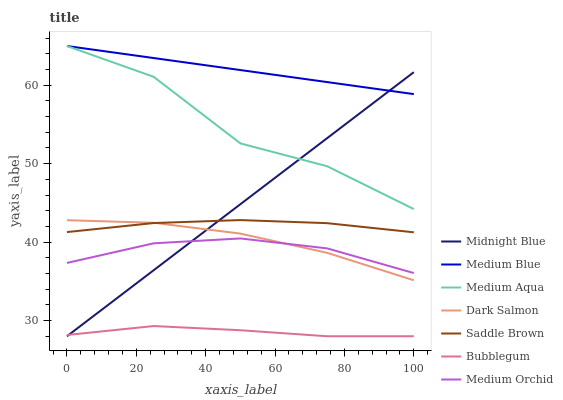Does Bubblegum have the minimum area under the curve?
Answer yes or no. Yes. Does Medium Blue have the maximum area under the curve?
Answer yes or no. Yes. Does Medium Orchid have the minimum area under the curve?
Answer yes or no. No. Does Medium Orchid have the maximum area under the curve?
Answer yes or no. No. Is Midnight Blue the smoothest?
Answer yes or no. Yes. Is Medium Aqua the roughest?
Answer yes or no. Yes. Is Medium Orchid the smoothest?
Answer yes or no. No. Is Medium Orchid the roughest?
Answer yes or no. No. Does Midnight Blue have the lowest value?
Answer yes or no. Yes. Does Medium Orchid have the lowest value?
Answer yes or no. No. Does Medium Aqua have the highest value?
Answer yes or no. Yes. Does Medium Orchid have the highest value?
Answer yes or no. No. Is Bubblegum less than Medium Blue?
Answer yes or no. Yes. Is Medium Orchid greater than Bubblegum?
Answer yes or no. Yes. Does Midnight Blue intersect Medium Orchid?
Answer yes or no. Yes. Is Midnight Blue less than Medium Orchid?
Answer yes or no. No. Is Midnight Blue greater than Medium Orchid?
Answer yes or no. No. Does Bubblegum intersect Medium Blue?
Answer yes or no. No. 